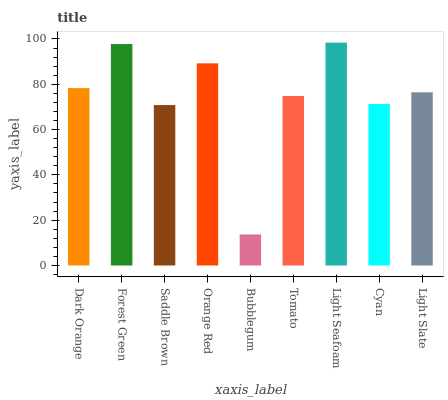Is Bubblegum the minimum?
Answer yes or no. Yes. Is Light Seafoam the maximum?
Answer yes or no. Yes. Is Forest Green the minimum?
Answer yes or no. No. Is Forest Green the maximum?
Answer yes or no. No. Is Forest Green greater than Dark Orange?
Answer yes or no. Yes. Is Dark Orange less than Forest Green?
Answer yes or no. Yes. Is Dark Orange greater than Forest Green?
Answer yes or no. No. Is Forest Green less than Dark Orange?
Answer yes or no. No. Is Light Slate the high median?
Answer yes or no. Yes. Is Light Slate the low median?
Answer yes or no. Yes. Is Dark Orange the high median?
Answer yes or no. No. Is Light Seafoam the low median?
Answer yes or no. No. 